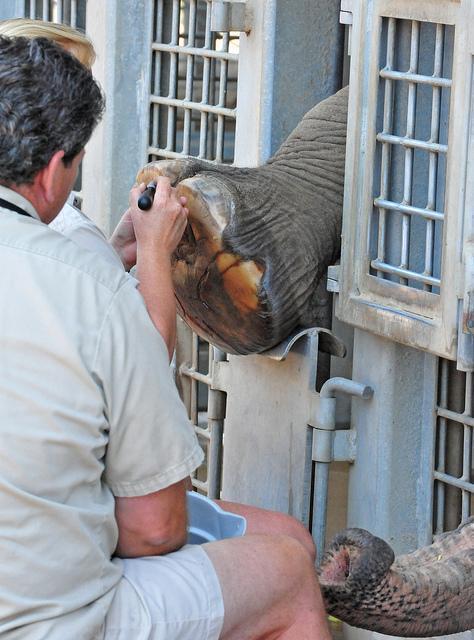Is the given caption "The person is on top of the elephant." fitting for the image?
Answer yes or no. No. 